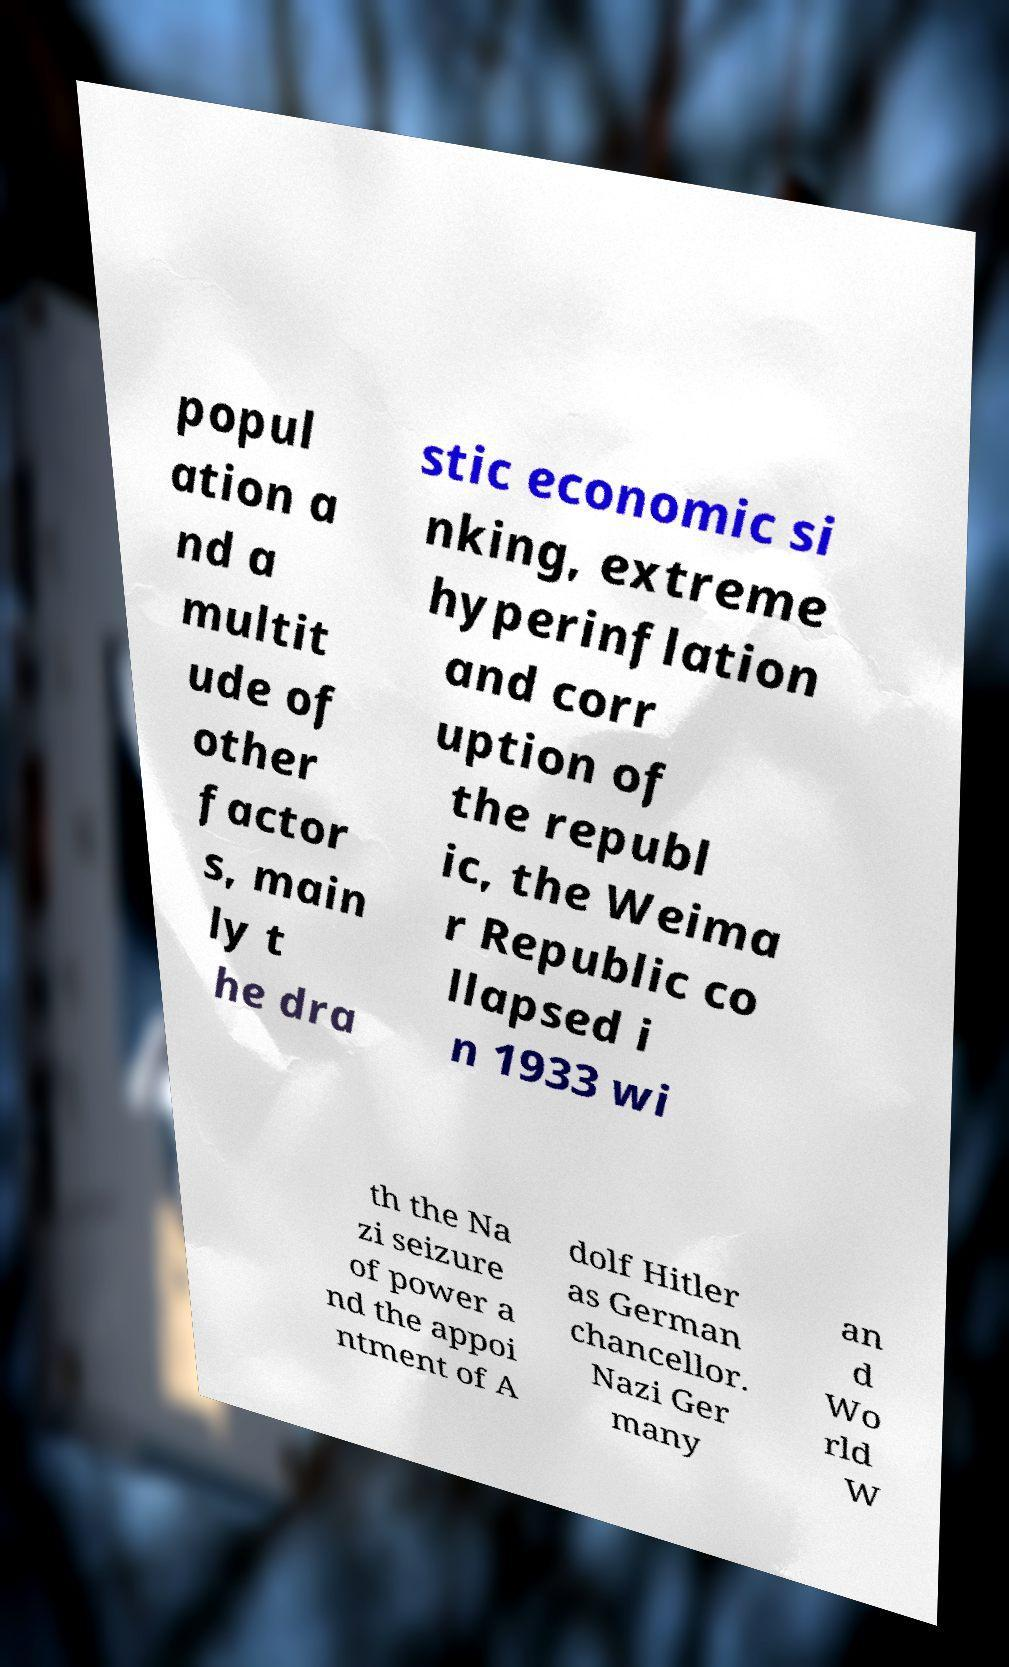Please identify and transcribe the text found in this image. popul ation a nd a multit ude of other factor s, main ly t he dra stic economic si nking, extreme hyperinflation and corr uption of the republ ic, the Weima r Republic co llapsed i n 1933 wi th the Na zi seizure of power a nd the appoi ntment of A dolf Hitler as German chancellor. Nazi Ger many an d Wo rld W 